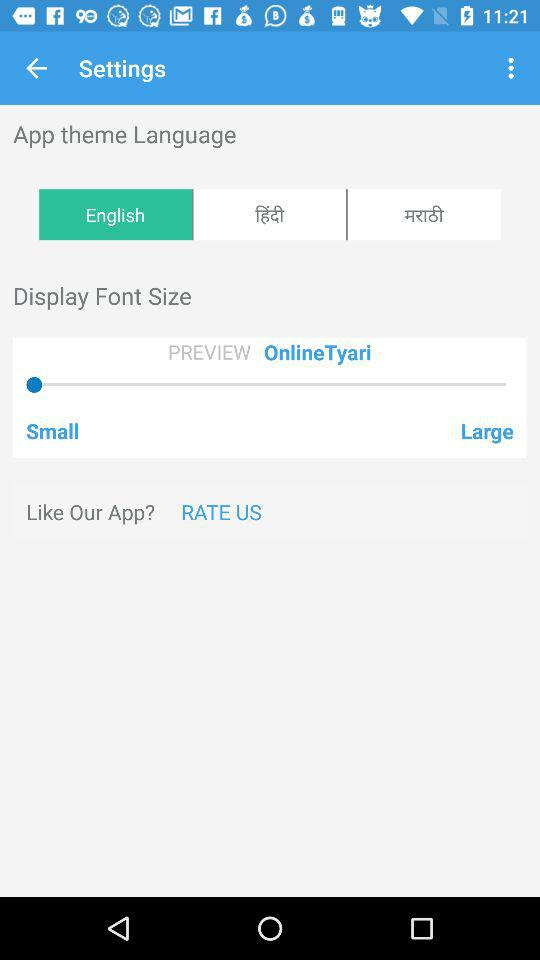What is the display font size? The display font size is small. 